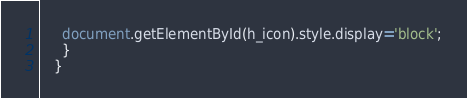Convert code to text. <code><loc_0><loc_0><loc_500><loc_500><_JavaScript_>     document.getElementById(h_icon).style.display='block';
     }
   }</code> 